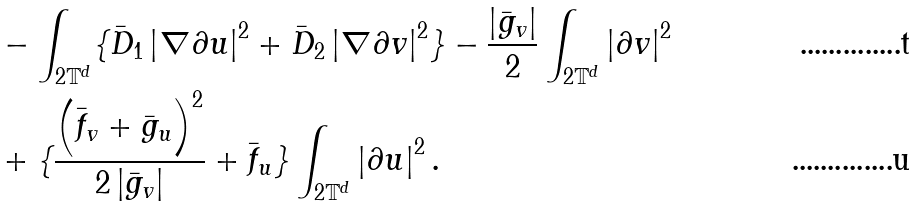<formula> <loc_0><loc_0><loc_500><loc_500>& - \int _ { 2 \mathbb { T } ^ { d } } \{ \bar { D } _ { 1 } \left | \nabla \partial u \right | ^ { 2 } + \bar { D } _ { 2 } \left | \nabla \partial v \right | ^ { 2 } \} - \frac { \left | \bar { g } _ { v } \right | } { 2 } \int _ { 2 \mathbb { T } ^ { d } } \left | \partial v \right | ^ { 2 } \\ & + \{ \frac { \left ( \bar { f } _ { v } + \bar { g } _ { u } \right ) ^ { 2 } } { 2 \left | \bar { g } _ { v } \right | } + \bar { f } _ { u } \} \int _ { 2 \mathbb { T } ^ { d } } \left | \partial u \right | ^ { 2 } .</formula> 